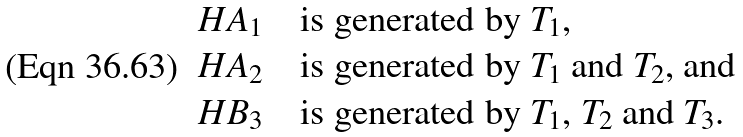Convert formula to latex. <formula><loc_0><loc_0><loc_500><loc_500>H A _ { 1 } & \quad \text {is generated by $T_{1}$,} \\ H A _ { 2 } & \quad \text {is generated by $T_{1}$ and $T_{2}$, and} \\ H B _ { 3 } & \quad \text {is generated by $T_{1}$, $T_{2}$ and $T_{3}$.}</formula> 